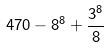Convert formula to latex. <formula><loc_0><loc_0><loc_500><loc_500>4 7 0 - 8 ^ { 8 } + \frac { 3 ^ { 8 } } { 8 }</formula> 